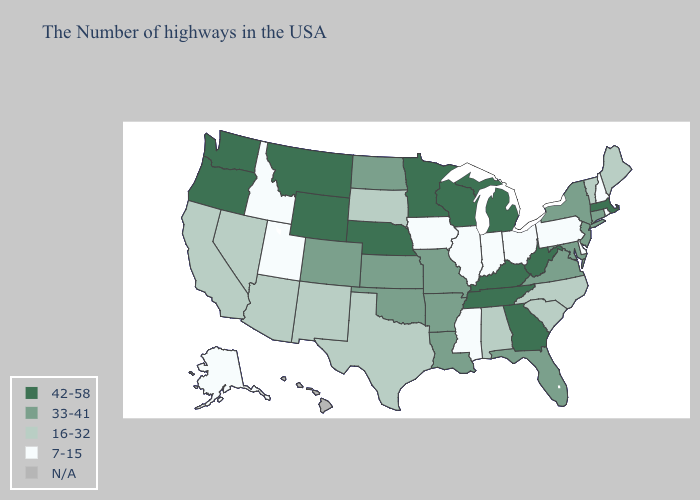Does the map have missing data?
Be succinct. Yes. Name the states that have a value in the range 16-32?
Write a very short answer. Maine, Vermont, North Carolina, South Carolina, Alabama, Texas, South Dakota, New Mexico, Arizona, Nevada, California. What is the highest value in states that border Kentucky?
Quick response, please. 42-58. What is the value of Washington?
Short answer required. 42-58. Does the first symbol in the legend represent the smallest category?
Concise answer only. No. What is the value of New Jersey?
Give a very brief answer. 33-41. Name the states that have a value in the range 7-15?
Answer briefly. Rhode Island, New Hampshire, Delaware, Pennsylvania, Ohio, Indiana, Illinois, Mississippi, Iowa, Utah, Idaho, Alaska. What is the value of West Virginia?
Write a very short answer. 42-58. Name the states that have a value in the range 16-32?
Answer briefly. Maine, Vermont, North Carolina, South Carolina, Alabama, Texas, South Dakota, New Mexico, Arizona, Nevada, California. Does Utah have the lowest value in the USA?
Be succinct. Yes. What is the value of Ohio?
Be succinct. 7-15. Among the states that border Kansas , does Nebraska have the highest value?
Concise answer only. Yes. What is the lowest value in the USA?
Keep it brief. 7-15. Does Georgia have the highest value in the South?
Answer briefly. Yes. 